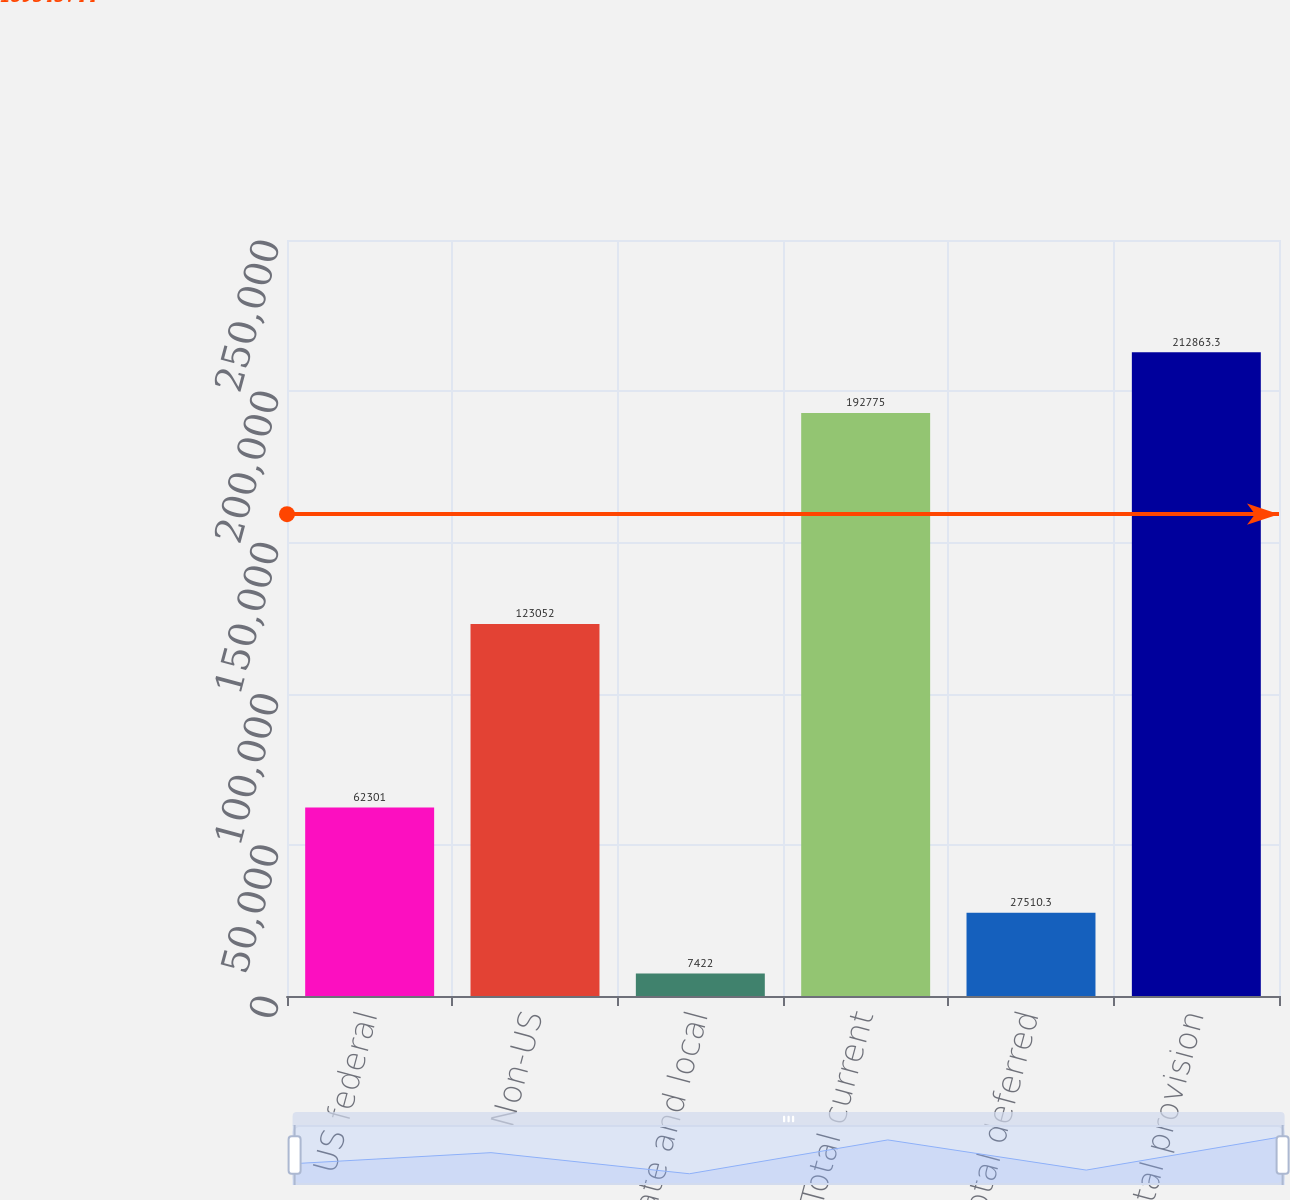Convert chart. <chart><loc_0><loc_0><loc_500><loc_500><bar_chart><fcel>US federal<fcel>Non-US<fcel>State and local<fcel>Total current<fcel>Total deferred<fcel>Total provision<nl><fcel>62301<fcel>123052<fcel>7422<fcel>192775<fcel>27510.3<fcel>212863<nl></chart> 